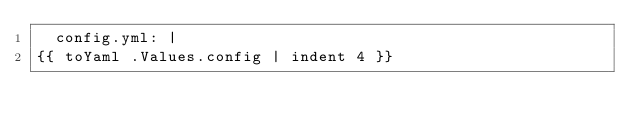<code> <loc_0><loc_0><loc_500><loc_500><_YAML_>  config.yml: |
{{ toYaml .Values.config | indent 4 }}
</code> 